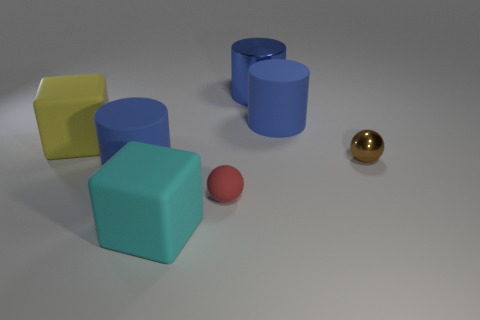Subtract all red spheres. Subtract all purple blocks. How many spheres are left? 1 Add 2 big green metallic spheres. How many objects exist? 9 Subtract all balls. How many objects are left? 5 Add 2 cyan matte things. How many cyan matte things are left? 3 Add 3 cyan matte blocks. How many cyan matte blocks exist? 4 Subtract 0 red cylinders. How many objects are left? 7 Subtract all small brown metal objects. Subtract all cyan blocks. How many objects are left? 5 